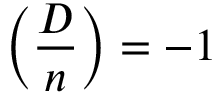<formula> <loc_0><loc_0><loc_500><loc_500>\left ( { \frac { D } { n } } \right ) = - 1</formula> 